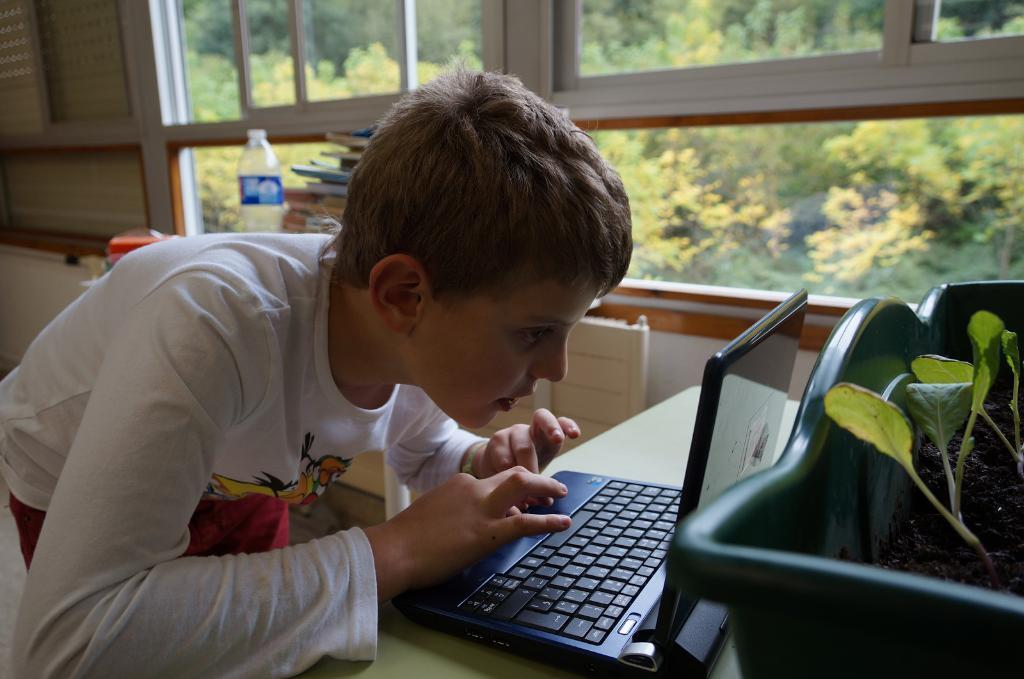Who is the main subject in the image? There is a boy in the image. What is the boy doing in the image? The boy is using a laptop on a table. What other objects can be seen in the image? There are plants in a plastic tub, books, and a water bottle in the image. What can be seen through the glass in the image? Trees are visible through a glass in the image. What type of crime is being committed in the image? There is no crime being committed in the image; it features a boy using a laptop on a table, plants in a plastic tub, books, a water bottle, and trees visible through a glass. Can you see any chickens or boats in the image? No, there are no chickens or boats present in the image. 